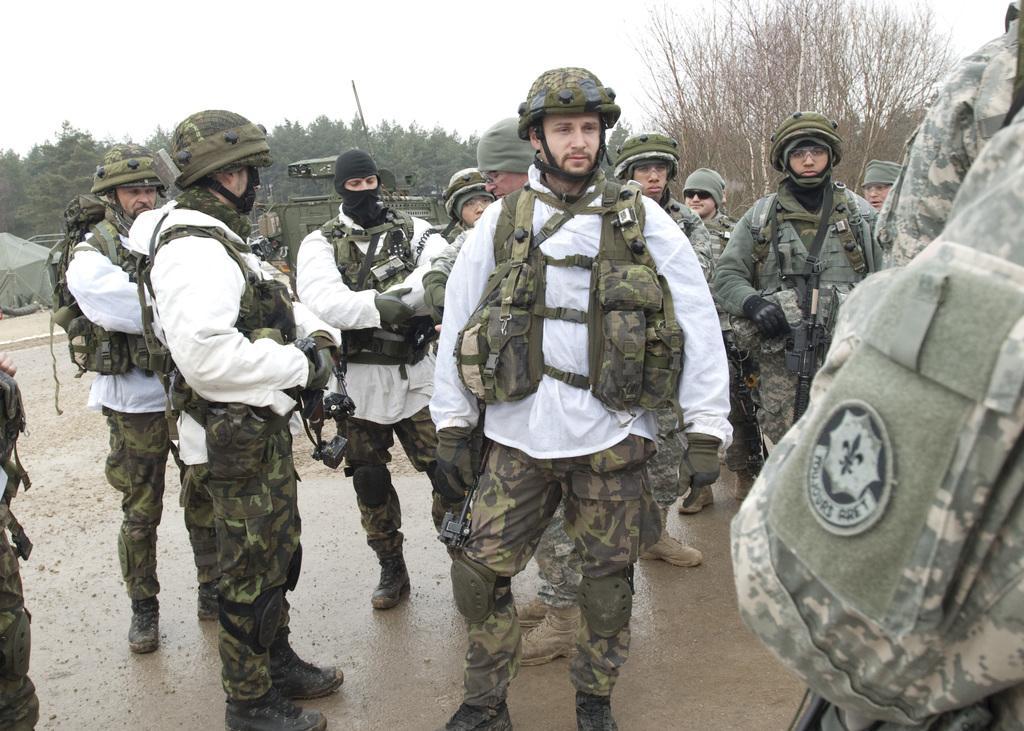Please provide a concise description of this image. In the background we can see the sky, trees, military object, tent. We can see the people wearing helmets, military jackets. A man on the left side is holding black object. At the bottom portion of the picture we can see the ground and its wet. 